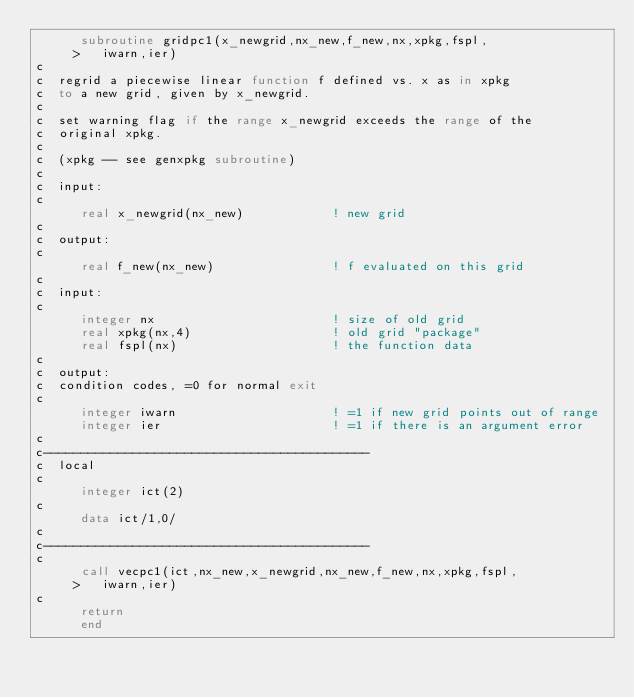Convert code to text. <code><loc_0><loc_0><loc_500><loc_500><_FORTRAN_>      subroutine gridpc1(x_newgrid,nx_new,f_new,nx,xpkg,fspl,
     >   iwarn,ier)
c
c  regrid a piecewise linear function f defined vs. x as in xpkg
c  to a new grid, given by x_newgrid.
c
c  set warning flag if the range x_newgrid exceeds the range of the
c  original xpkg.
c
c  (xpkg -- see genxpkg subroutine)
c
c  input:
c
      real x_newgrid(nx_new)            ! new grid
c
c  output:
c
      real f_new(nx_new)                ! f evaluated on this grid
c
c  input:
c
      integer nx                        ! size of old grid
      real xpkg(nx,4)                   ! old grid "package"
      real fspl(nx)                     ! the function data
c
c  output:
c  condition codes, =0 for normal exit
c
      integer iwarn                     ! =1 if new grid points out of range
      integer ier                       ! =1 if there is an argument error
c
c--------------------------------------------
c  local
c
      integer ict(2)
c
      data ict/1,0/
c
c--------------------------------------------
c
      call vecpc1(ict,nx_new,x_newgrid,nx_new,f_new,nx,xpkg,fspl,
     >   iwarn,ier)
c
      return
      end
</code> 